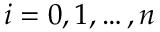<formula> <loc_0><loc_0><loc_500><loc_500>i = 0 , 1 , \dots , n</formula> 